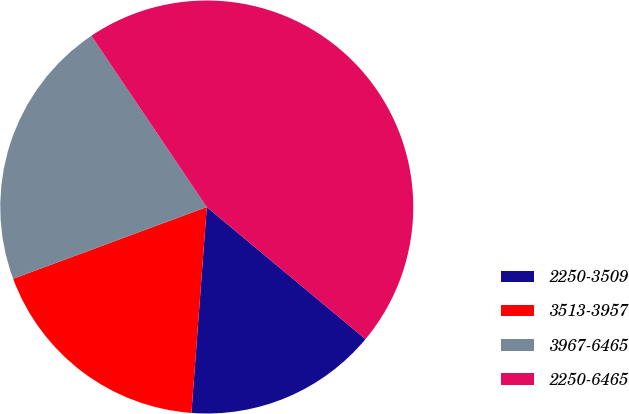<chart> <loc_0><loc_0><loc_500><loc_500><pie_chart><fcel>2250-3509<fcel>3513-3957<fcel>3967-6465<fcel>2250-6465<nl><fcel>15.14%<fcel>18.17%<fcel>21.21%<fcel>45.48%<nl></chart> 